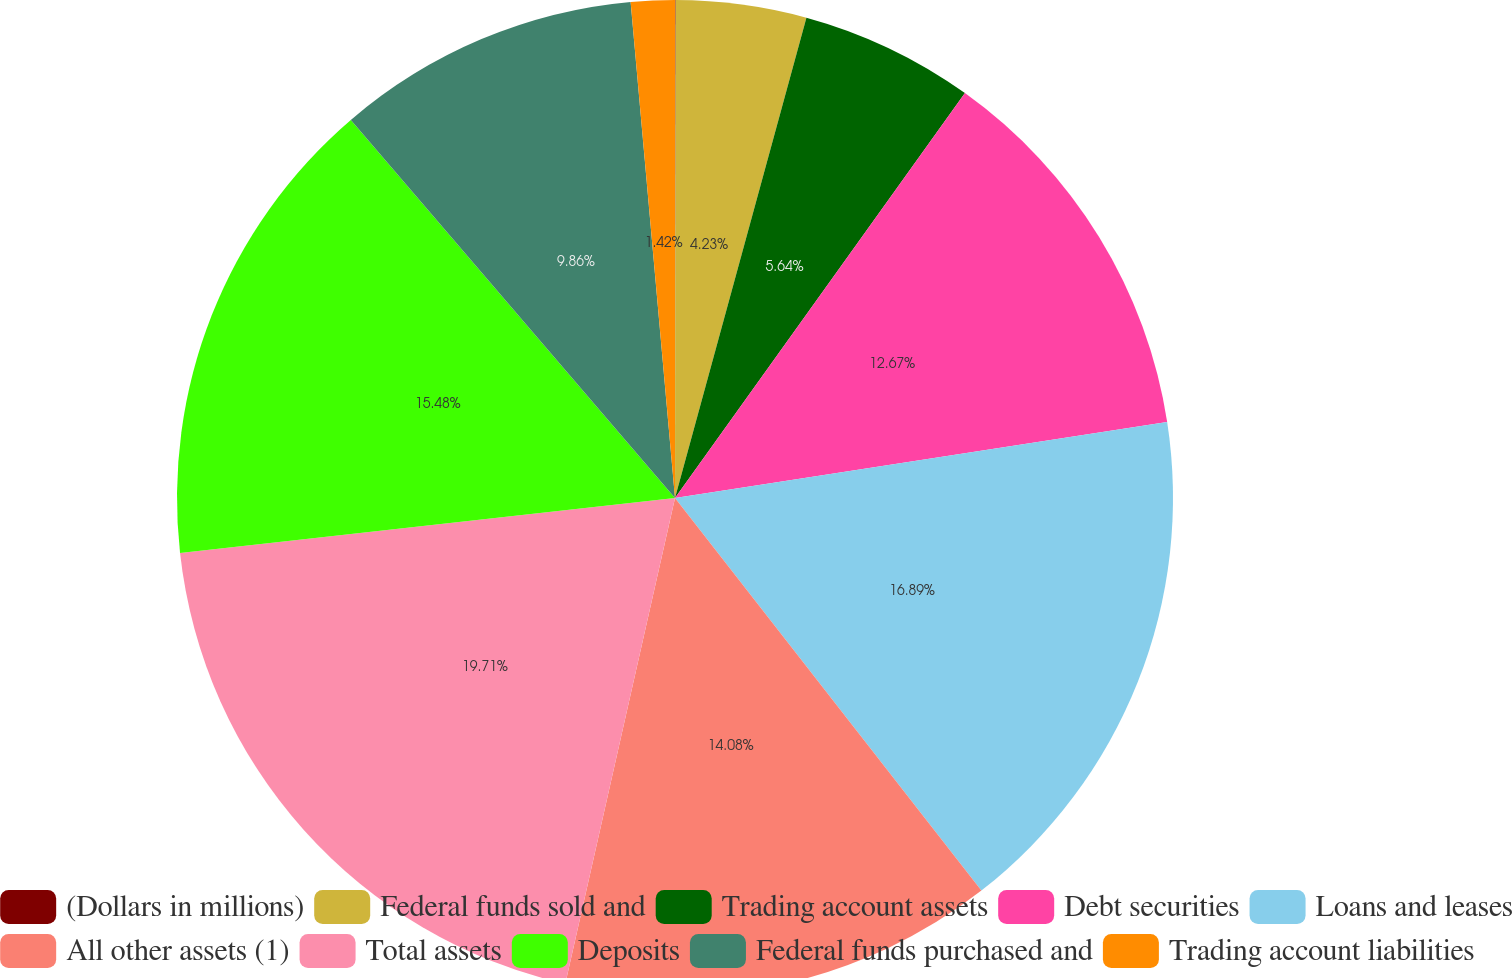<chart> <loc_0><loc_0><loc_500><loc_500><pie_chart><fcel>(Dollars in millions)<fcel>Federal funds sold and<fcel>Trading account assets<fcel>Debt securities<fcel>Loans and leases<fcel>All other assets (1)<fcel>Total assets<fcel>Deposits<fcel>Federal funds purchased and<fcel>Trading account liabilities<nl><fcel>0.02%<fcel>4.23%<fcel>5.64%<fcel>12.67%<fcel>16.89%<fcel>14.08%<fcel>19.7%<fcel>15.48%<fcel>9.86%<fcel>1.42%<nl></chart> 